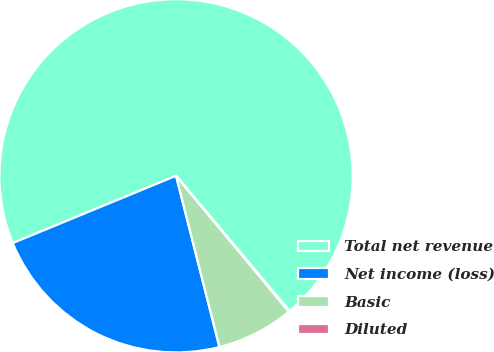Convert chart. <chart><loc_0><loc_0><loc_500><loc_500><pie_chart><fcel>Total net revenue<fcel>Net income (loss)<fcel>Basic<fcel>Diluted<nl><fcel>70.11%<fcel>22.73%<fcel>7.08%<fcel>0.08%<nl></chart> 